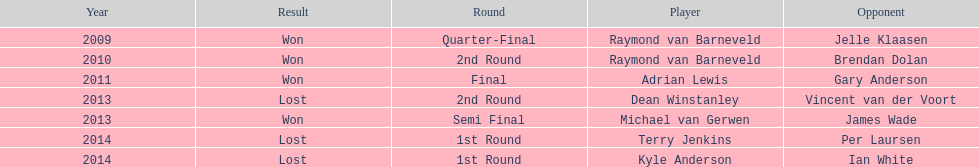How many champions were from norway? 0. 